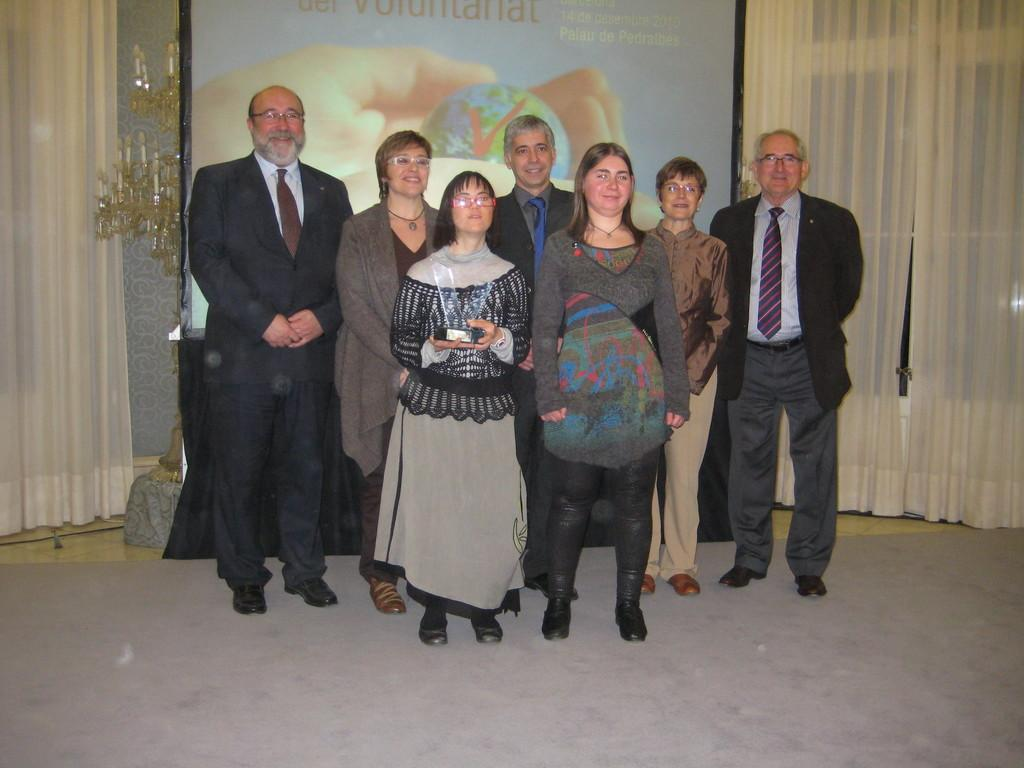What are the people in the image doing? The people in the image are standing in the center. What is behind the people in the image? There is a banner behind the people. What can be seen on the left side of the image? There are candles on the left side of the image. What is associated with the candles? There is a curtain associated with the candles. What is on the right side of the image? There is a window on the right side of the image. What is associated with the window? There are curtains associated with the window. How many feathers can be seen floating around the people in the image? There are no feathers visible in the image. What type of bead is being used to decorate the candles in the image? There is no mention of beads or any decorations on the candles in the image. 